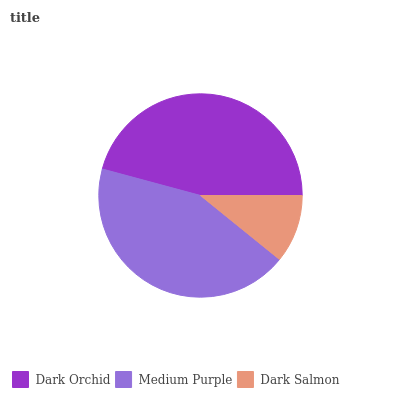Is Dark Salmon the minimum?
Answer yes or no. Yes. Is Dark Orchid the maximum?
Answer yes or no. Yes. Is Medium Purple the minimum?
Answer yes or no. No. Is Medium Purple the maximum?
Answer yes or no. No. Is Dark Orchid greater than Medium Purple?
Answer yes or no. Yes. Is Medium Purple less than Dark Orchid?
Answer yes or no. Yes. Is Medium Purple greater than Dark Orchid?
Answer yes or no. No. Is Dark Orchid less than Medium Purple?
Answer yes or no. No. Is Medium Purple the high median?
Answer yes or no. Yes. Is Medium Purple the low median?
Answer yes or no. Yes. Is Dark Salmon the high median?
Answer yes or no. No. Is Dark Orchid the low median?
Answer yes or no. No. 